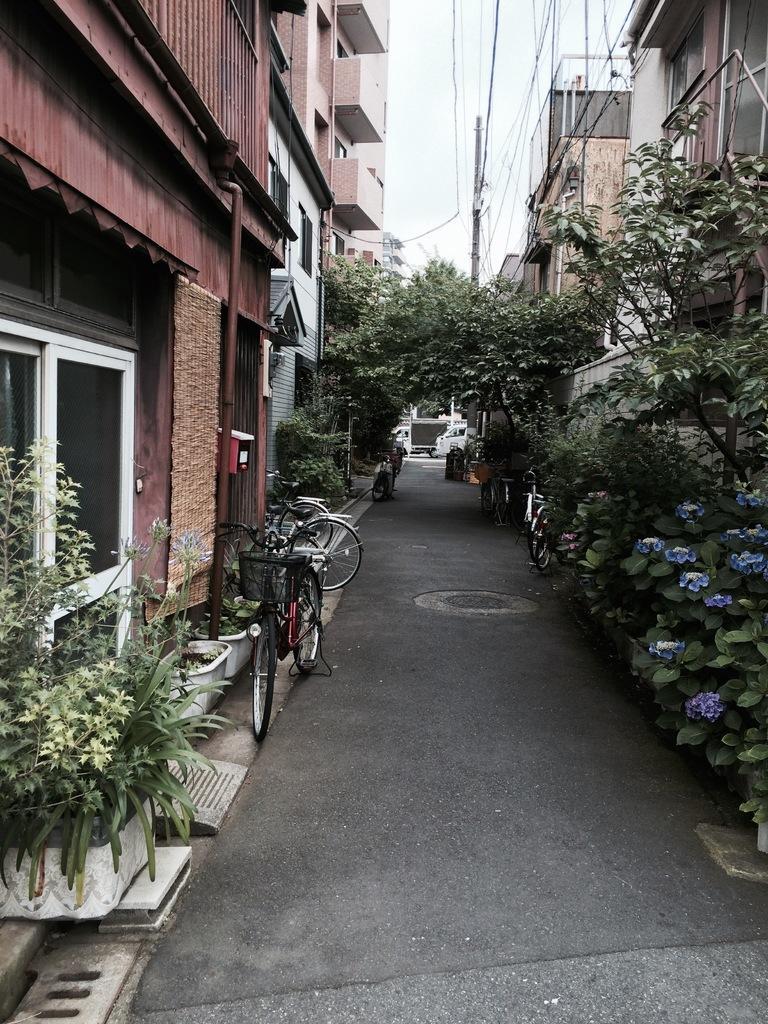Could you give a brief overview of what you see in this image? These are the buildings with the doors. I can see the bicycles, which are beside the road. These are the trees with branches and leaves. I think these are the flower pots with the plants. I can see the flowers. This is a road. This looks like a current pole with the current wires. 